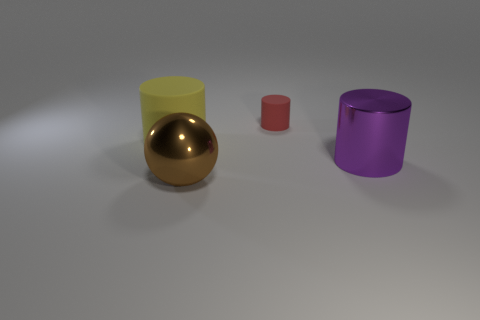Are there any tiny red objects of the same shape as the big matte object?
Offer a terse response. Yes. What number of big yellow rubber things are there?
Your answer should be compact. 1. The big brown metal thing has what shape?
Provide a short and direct response. Sphere. How many spheres have the same size as the red thing?
Your answer should be compact. 0. Is the shape of the purple object the same as the tiny red thing?
Make the answer very short. Yes. There is a rubber thing on the right side of the big cylinder that is on the left side of the large purple cylinder; what is its color?
Keep it short and to the point. Red. There is a thing that is behind the brown metal sphere and in front of the large rubber cylinder; how big is it?
Offer a very short reply. Large. Are there any other things that are the same color as the large rubber cylinder?
Make the answer very short. No. There is another big object that is the same material as the red object; what shape is it?
Your answer should be very brief. Cylinder. There is a large purple shiny object; is its shape the same as the rubber thing that is right of the ball?
Your answer should be compact. Yes. 